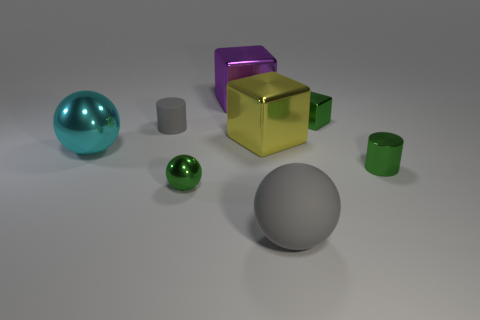There is a big object that is the same color as the rubber cylinder; what is it made of?
Give a very brief answer. Rubber. There is a cylinder that is behind the cylinder in front of the cyan shiny thing; are there any tiny shiny cubes in front of it?
Provide a short and direct response. No. Is the number of big blocks that are on the right side of the large gray sphere less than the number of small gray things in front of the small cube?
Your answer should be compact. Yes. What is the color of the large sphere that is made of the same material as the gray cylinder?
Your answer should be very brief. Gray. The large block that is in front of the small shiny object that is behind the cyan metallic sphere is what color?
Your response must be concise. Yellow. Is there a large rubber sphere that has the same color as the small rubber thing?
Offer a terse response. Yes. There is a purple thing that is the same size as the yellow thing; what is its shape?
Your answer should be compact. Cube. There is a big purple metallic object that is on the right side of the gray cylinder; what number of large cyan objects are on the left side of it?
Your answer should be compact. 1. Is the color of the matte sphere the same as the small cube?
Give a very brief answer. No. How many other objects are the same material as the gray ball?
Offer a terse response. 1. 